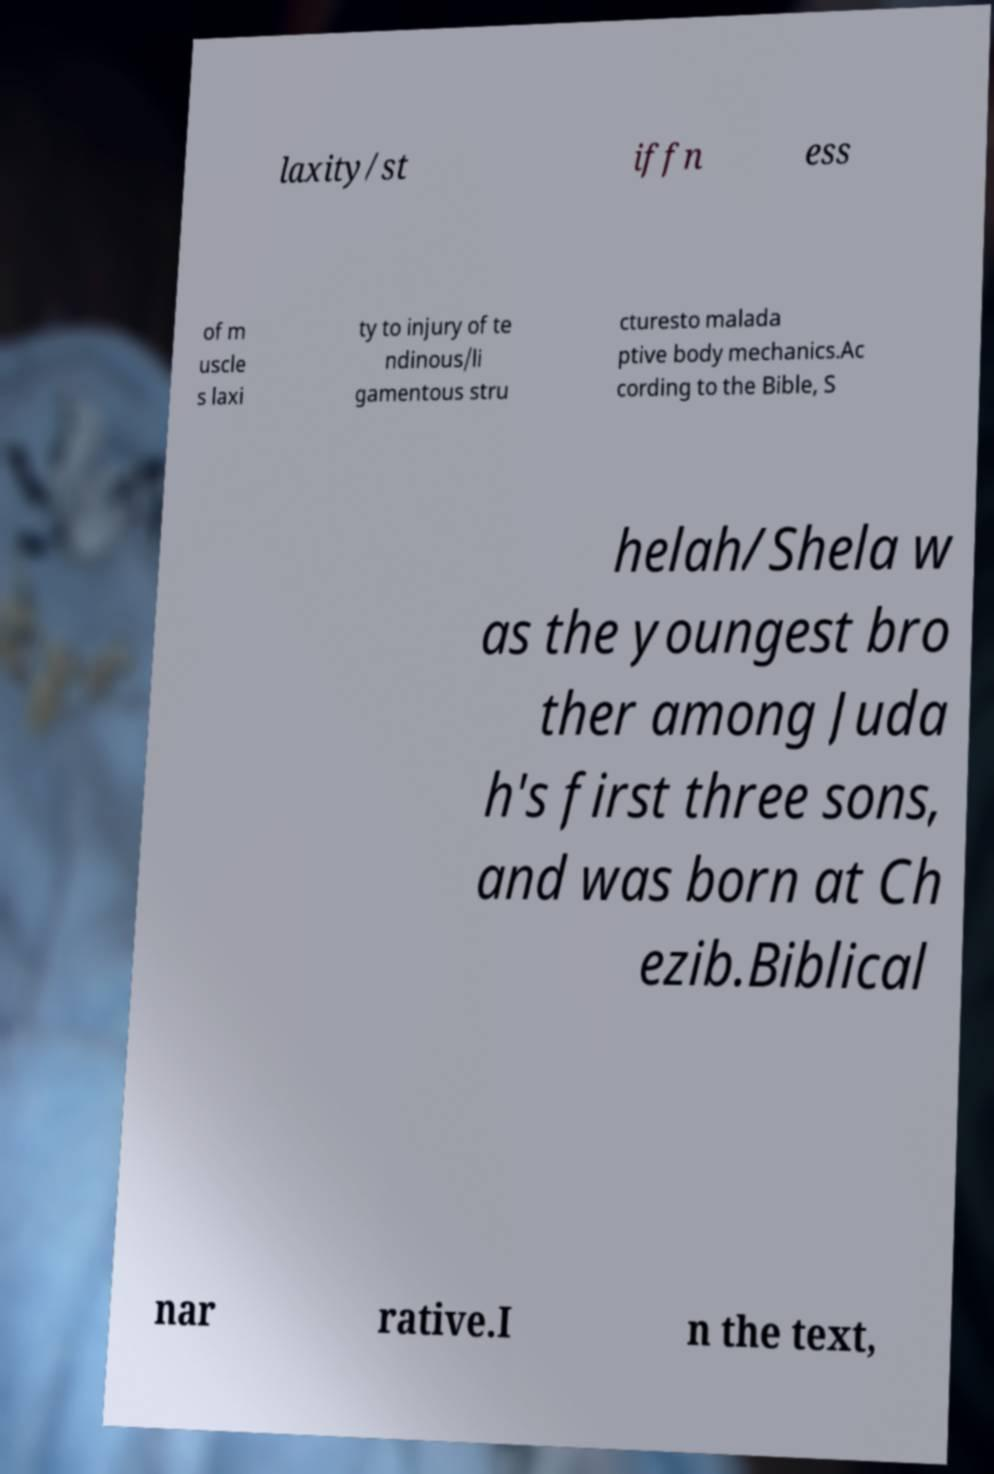I need the written content from this picture converted into text. Can you do that? laxity/st iffn ess of m uscle s laxi ty to injury of te ndinous/li gamentous stru cturesto malada ptive body mechanics.Ac cording to the Bible, S helah/Shela w as the youngest bro ther among Juda h's first three sons, and was born at Ch ezib.Biblical nar rative.I n the text, 